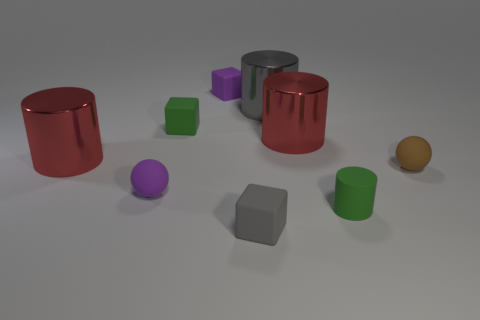What color is the block in front of the small rubber cylinder?
Ensure brevity in your answer.  Gray. Do the large cylinder on the left side of the big gray shiny object and the small brown thing have the same material?
Offer a very short reply. No. How many things are both to the left of the brown thing and behind the small purple ball?
Keep it short and to the point. 5. What is the color of the metallic object that is on the left side of the gray thing behind the small purple rubber thing to the left of the green cube?
Your answer should be compact. Red. What number of other things are there of the same shape as the large gray thing?
Your answer should be very brief. 3. There is a rubber sphere on the left side of the tiny gray rubber thing; is there a cube that is in front of it?
Your answer should be compact. Yes. What number of rubber objects are either big gray things or tiny objects?
Offer a terse response. 6. What material is the object that is both behind the small brown thing and on the left side of the green matte cube?
Keep it short and to the point. Metal. There is a metal cylinder to the left of the ball left of the tiny gray cube; is there a tiny gray rubber object that is behind it?
Make the answer very short. No. Is there anything else that has the same material as the brown object?
Give a very brief answer. Yes. 